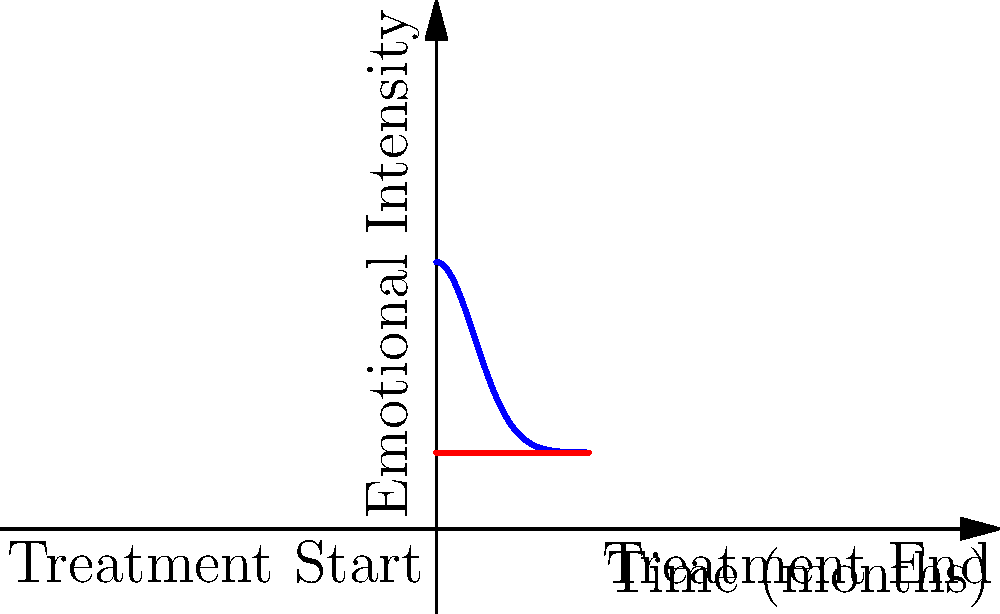The graph above represents the emotional intensity $f(x)$ experienced by an artist during a 4-month infertility treatment period, where $x$ is time in months. The function $f(x) = 5e^{-0.5x^2} + 2$ models this emotional intensity. Calculate the total emotional experience, represented by the area between $f(x)$ and the baseline emotional state $y=2$, over the entire treatment period. To solve this problem, we need to follow these steps:

1) The area we're looking for is the difference between the area under $f(x)$ and the area under $y=2$ from $x=0$ to $x=4$.

2) We can express this mathematically as:

   $$\int_0^4 (f(x) - 2) dx = \int_0^4 (5e^{-0.5x^2} + 2 - 2) dx = \int_0^4 5e^{-0.5x^2} dx$$

3) This integral doesn't have an elementary antiderivative, so we need to use numerical integration. We can use the error function (erf) to solve this:

   $$\int_0^4 5e^{-0.5x^2} dx = 5\sqrt{\frac{\pi}{0.5}} \cdot \frac{\text{erf}(4\sqrt{0.5}) - \text{erf}(0)}{2}$$

4) Simplify:
   $$= 5\sqrt{2\pi} \cdot \frac{\text{erf}(2\sqrt{2}) - 0}{2}$$

5) Calculate:
   $$\approx 5\sqrt{2\pi} \cdot \frac{0.9953 - 0}{2} \approx 8.8582$$

Therefore, the total emotional experience above the baseline is approximately 8.8582 emotional intensity-months.
Answer: 8.8582 emotional intensity-months 